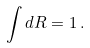<formula> <loc_0><loc_0><loc_500><loc_500>\int d R = 1 \, .</formula> 